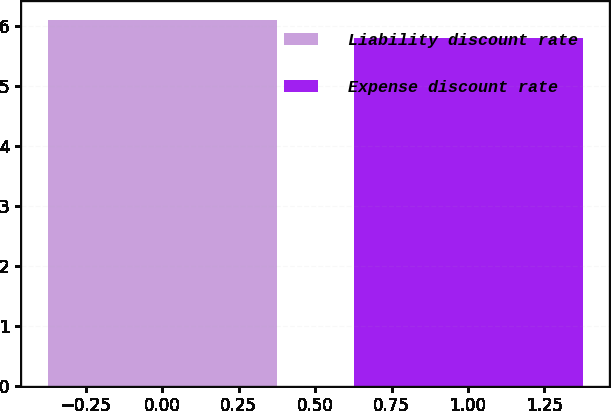<chart> <loc_0><loc_0><loc_500><loc_500><bar_chart><fcel>Liability discount rate<fcel>Expense discount rate<nl><fcel>6.1<fcel>5.8<nl></chart> 